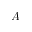Convert formula to latex. <formula><loc_0><loc_0><loc_500><loc_500>A</formula> 